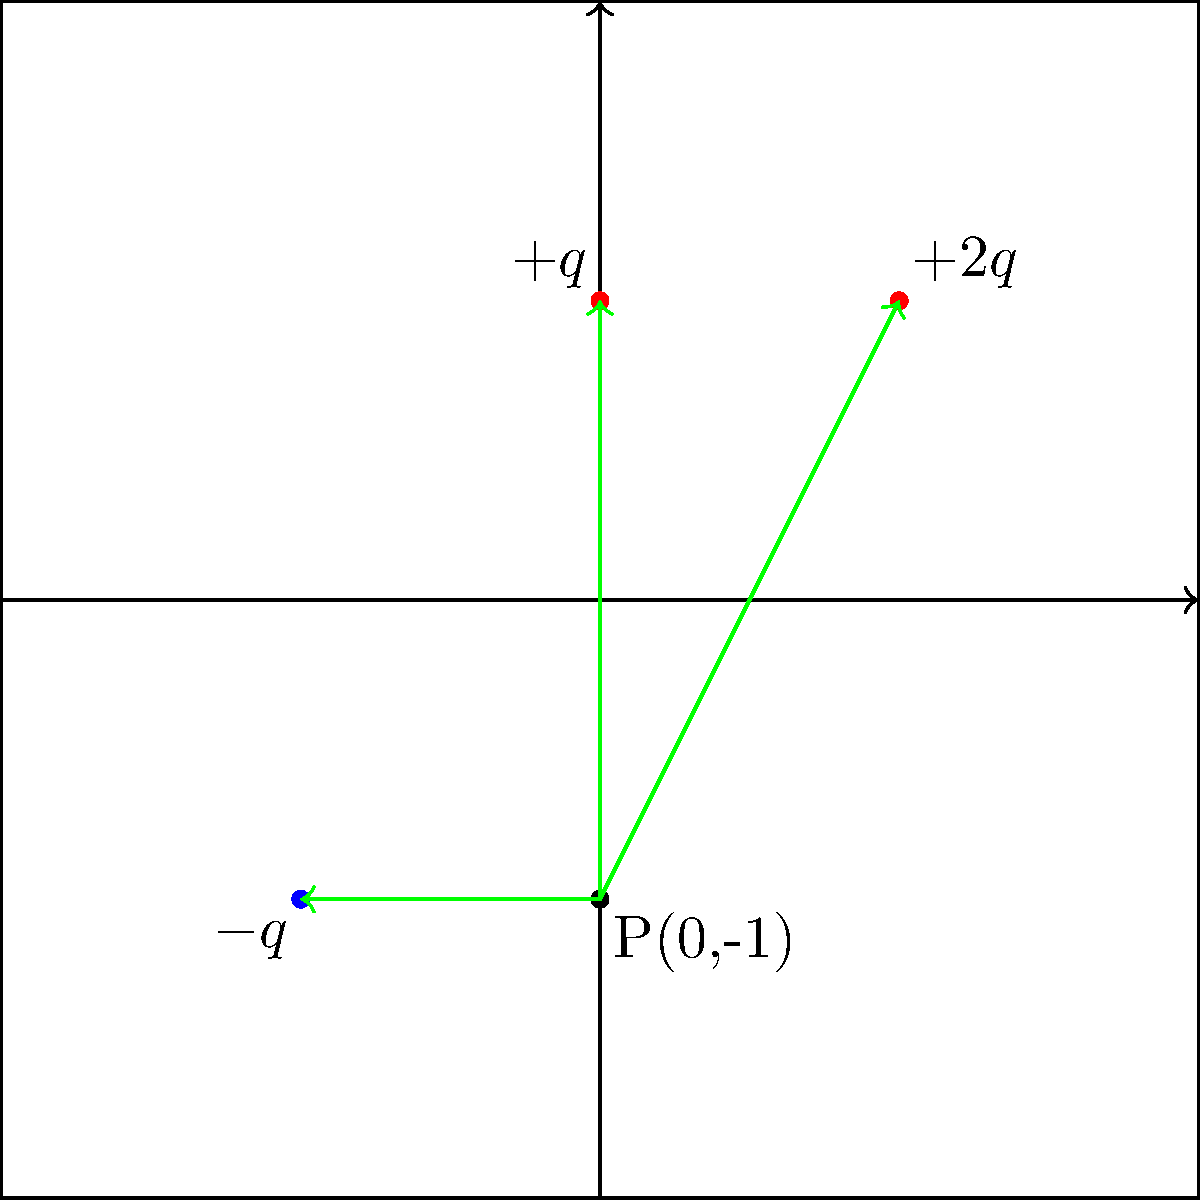In the 2D plane shown above, three point charges are positioned as follows: $+2q$ at (1,1), $-q$ at (-1,-1), and $+q$ at (0,1), where $q = 2.0 \times 10^{-9}$ C. Calculate the magnitude of the electric field strength at point P(0,-1) in N/C. Assume $k = 9.0 \times 10^9$ N⋅m²/C². To solve this problem, we'll follow these steps:

1) Calculate the distance from each charge to point P:
   $r_1 = \sqrt{(1-0)^2 + (1+1)^2} = \sqrt{5}$ m
   $r_2 = \sqrt{(-1-0)^2 + (-1+1)^2} = \sqrt{2}$ m
   $r_3 = \sqrt{(0-0)^2 + (1+1)^2} = 2$ m

2) Calculate the magnitude of the electric field from each charge:
   $E_1 = k\frac{|q_1|}{r_1^2} = 9.0 \times 10^9 \cdot \frac{4.0 \times 10^{-9}}{5} = 7.2$ N/C
   $E_2 = k\frac{|q_2|}{r_2^2} = 9.0 \times 10^9 \cdot \frac{2.0 \times 10^{-9}}{2} = 9.0$ N/C
   $E_3 = k\frac{|q_3|}{r_3^2} = 9.0 \times 10^9 \cdot \frac{2.0 \times 10^{-9}}{4} = 4.5$ N/C

3) Calculate the x and y components of each field:
   $E_{1x} = E_1 \cdot \frac{1}{\sqrt{5}} = 3.22$ N/C, $E_{1y} = E_1 \cdot \frac{2}{\sqrt{5}} = 6.44$ N/C
   $E_{2x} = E_2 \cdot \frac{1}{\sqrt{2}} = 6.36$ N/C, $E_{2y} = E_2 \cdot \frac{0}{\sqrt{2}} = 0$ N/C
   $E_{3x} = 0$ N/C, $E_{3y} = E_3 = 4.5$ N/C

4) Sum the x and y components:
   $E_x = E_{1x} - E_{2x} + E_{3x} = 3.22 - 6.36 + 0 = -3.14$ N/C
   $E_y = E_{1y} + E_{2y} + E_{3y} = 6.44 + 0 + 4.5 = 10.94$ N/C

5) Calculate the magnitude of the resultant field:
   $E = \sqrt{E_x^2 + E_y^2} = \sqrt{(-3.14)^2 + (10.94)^2} = 11.39$ N/C
Answer: 11.39 N/C 